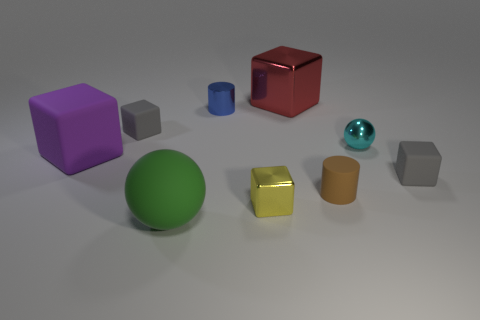Which objects in the image have a cylindrical shape? In the image, the small cyan object and the yellow object to its left are both cylindrical in shape. 